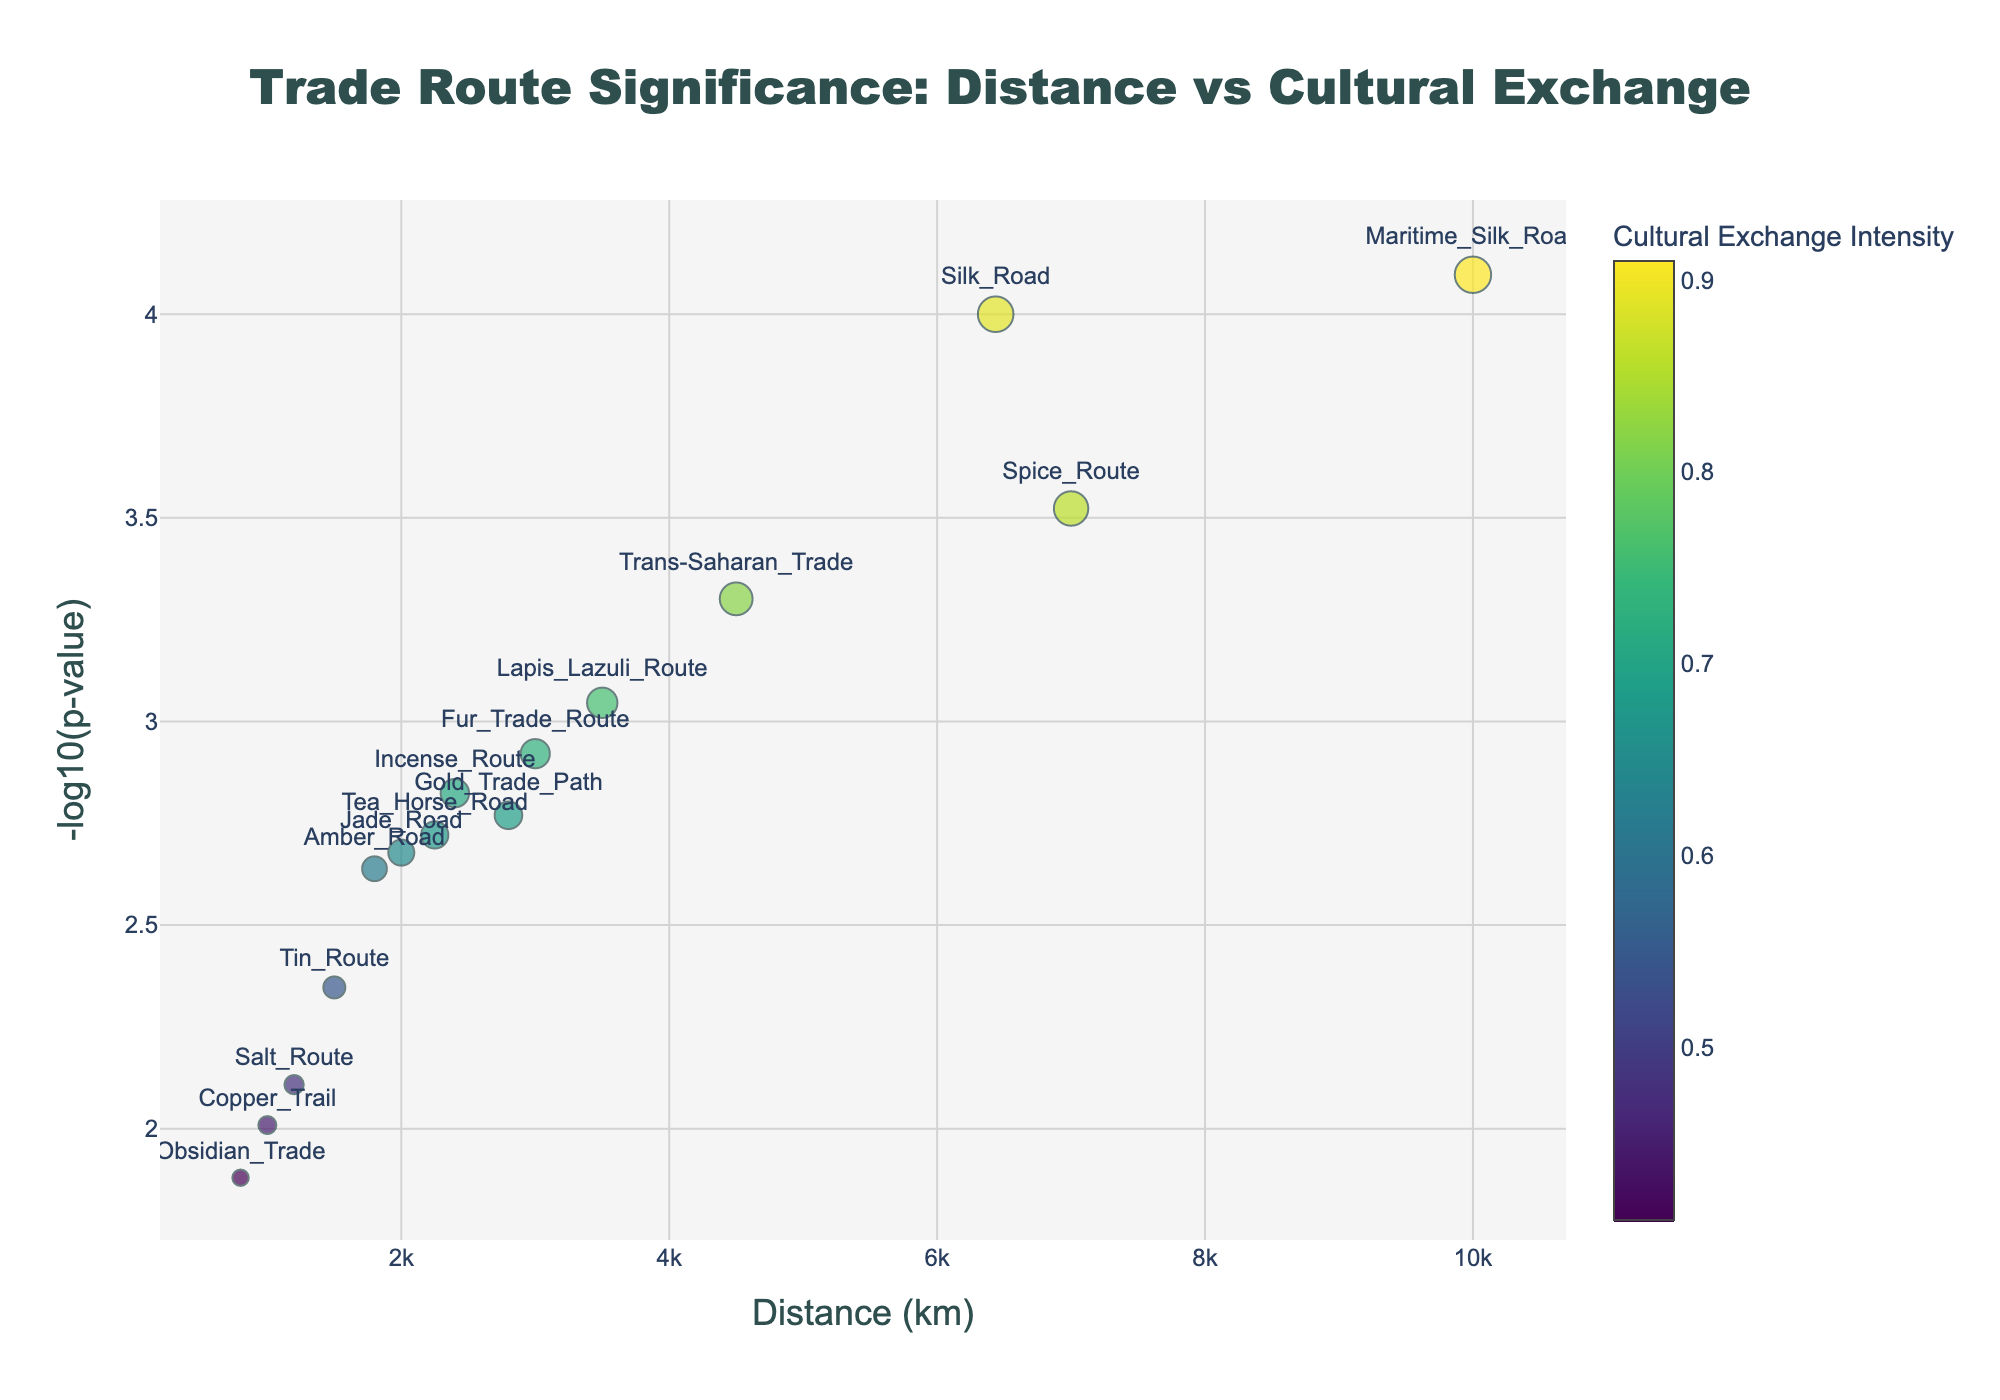What's the title of the plot? The title is located at the top center of the plot and is explicitly displayed to describe the figure.
Answer: Trade Route Significance: Distance vs Cultural Exchange What do the x-axis and y-axis represent in this plot? The x-axis represents the distance of the trade route in kilometers, and the y-axis represents the negative log (base 10) of the p-value. This information is clearly displayed as axis titles on the plot.
Answer: The x-axis represents distance (km) and the y-axis represents -log10(p-value) How many trade routes are represented in the plot? By counting the number of labeled markers in the plot, one can determine the total number of trade routes.
Answer: 15 Which trade route has the highest cultural exchange intensity? The trade route with the largest marker size and darkest color on the Viridis color scale will have the highest cultural exchange intensity.
Answer: Maritime Silk Road Which trade route is the closest in terms of distance? The plot shows the distance on the x-axis. The closest trade route will have the smallest x-coordinate value.
Answer: Obsidian Trade What is the p-value range used in the plot? The p-value range can be deduced from the -log10(p-value) displayed on the y-axis. To find the range, exponentiate the range of y-values.
Answer: ~1e-5 to 1e-3 Which two trade routes have the closest cultural exchange intensity values? By comparing the marker sizes and colors of the routes, we can find pairs that have similar appearances.
Answer: Jade Road and Amber Road How does the distance of the Silk Road compare to the Maritime Silk Road? Compare the x-coordinates of the points labeled 'Silk Road' and 'Maritime Silk Road'.
Answer: Silk Road is shorter What is the trend between distance and cultural exchange intensity? By observing the distribution of points along the x-axis and the corresponding marker sizes/colors, one can infer the trend.
Answer: No clear trend Which trade route shows the most statistically significant cultural exchange? The route with the highest -log10(p-value) value (i.e., the highest y-coordinate) is the most statistically significant.
Answer: Maritime Silk Road 